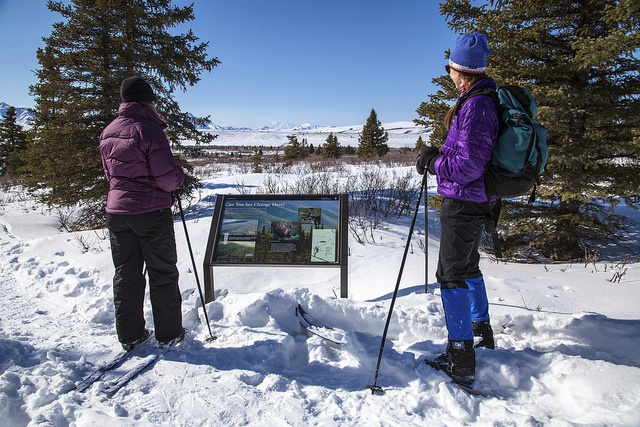Describe the objects in this image and their specific colors. I can see people in blue, black, navy, purple, and darkblue tones, people in blue, black, purple, and gray tones, backpack in blue, black, darkblue, and darkgreen tones, skis in blue, gray, darkgray, navy, and lightgray tones, and skis in blue, lightgray, gray, and black tones in this image. 